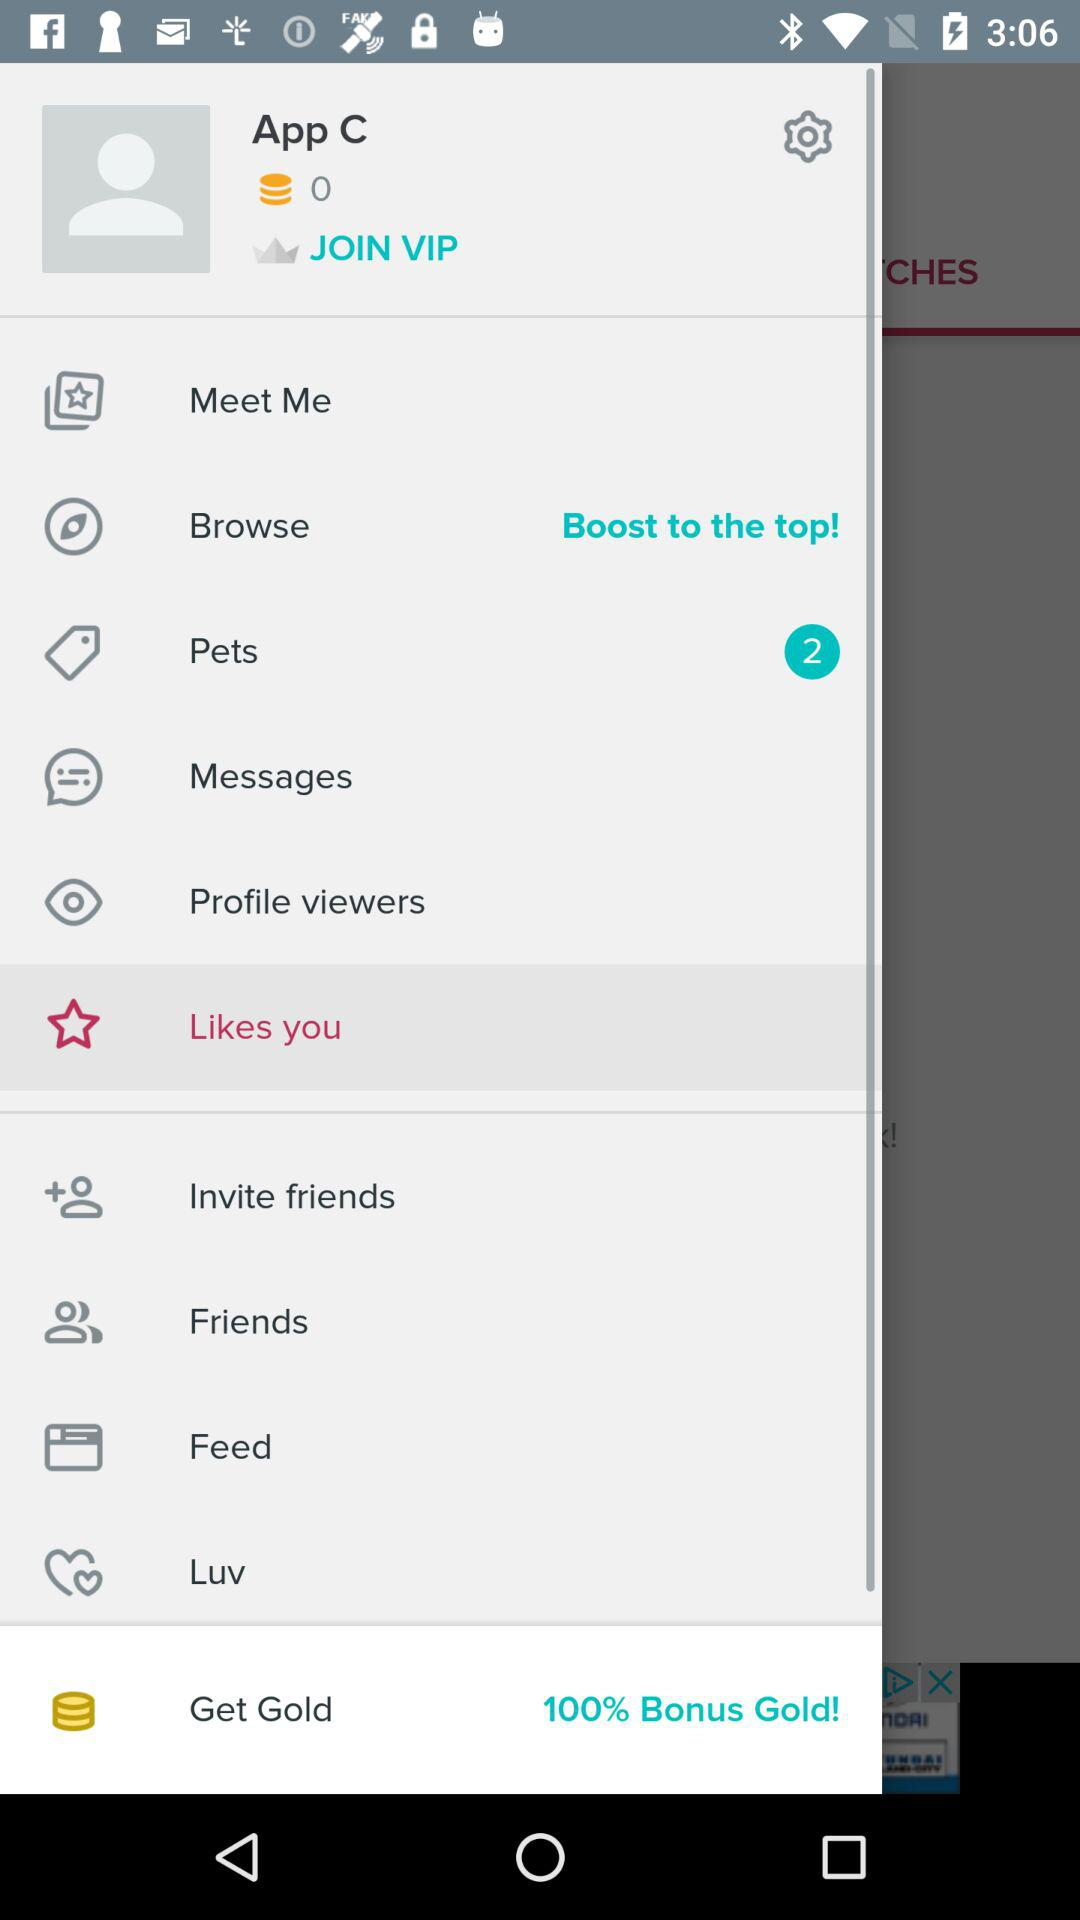How many coins does App C have? App C has 0 coins. 